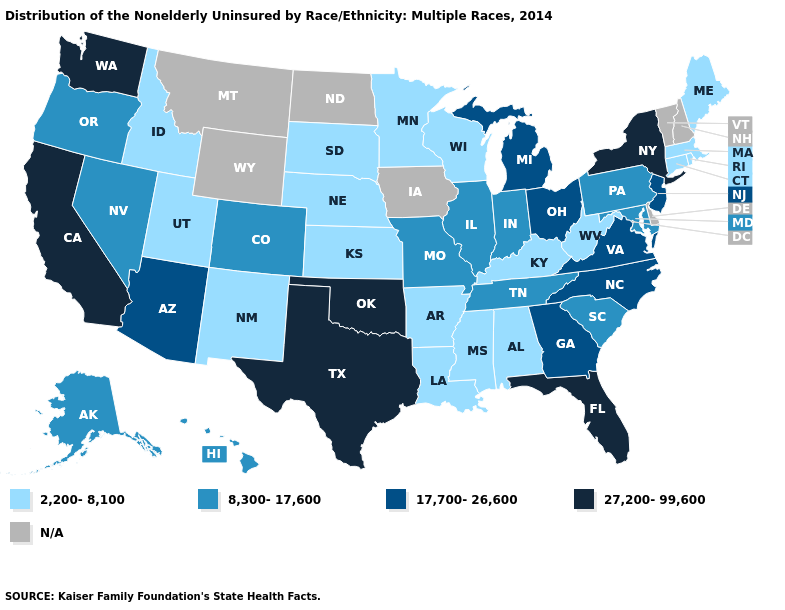What is the value of Mississippi?
Be succinct. 2,200-8,100. What is the highest value in the USA?
Answer briefly. 27,200-99,600. Name the states that have a value in the range 27,200-99,600?
Write a very short answer. California, Florida, New York, Oklahoma, Texas, Washington. What is the lowest value in the MidWest?
Keep it brief. 2,200-8,100. Does Idaho have the highest value in the USA?
Write a very short answer. No. What is the lowest value in the USA?
Concise answer only. 2,200-8,100. Name the states that have a value in the range 27,200-99,600?
Give a very brief answer. California, Florida, New York, Oklahoma, Texas, Washington. What is the value of Illinois?
Short answer required. 8,300-17,600. Which states hav the highest value in the MidWest?
Write a very short answer. Michigan, Ohio. Does the map have missing data?
Give a very brief answer. Yes. Does California have the highest value in the USA?
Keep it brief. Yes. How many symbols are there in the legend?
Write a very short answer. 5. What is the lowest value in states that border Texas?
Keep it brief. 2,200-8,100. What is the lowest value in states that border South Carolina?
Be succinct. 17,700-26,600. 